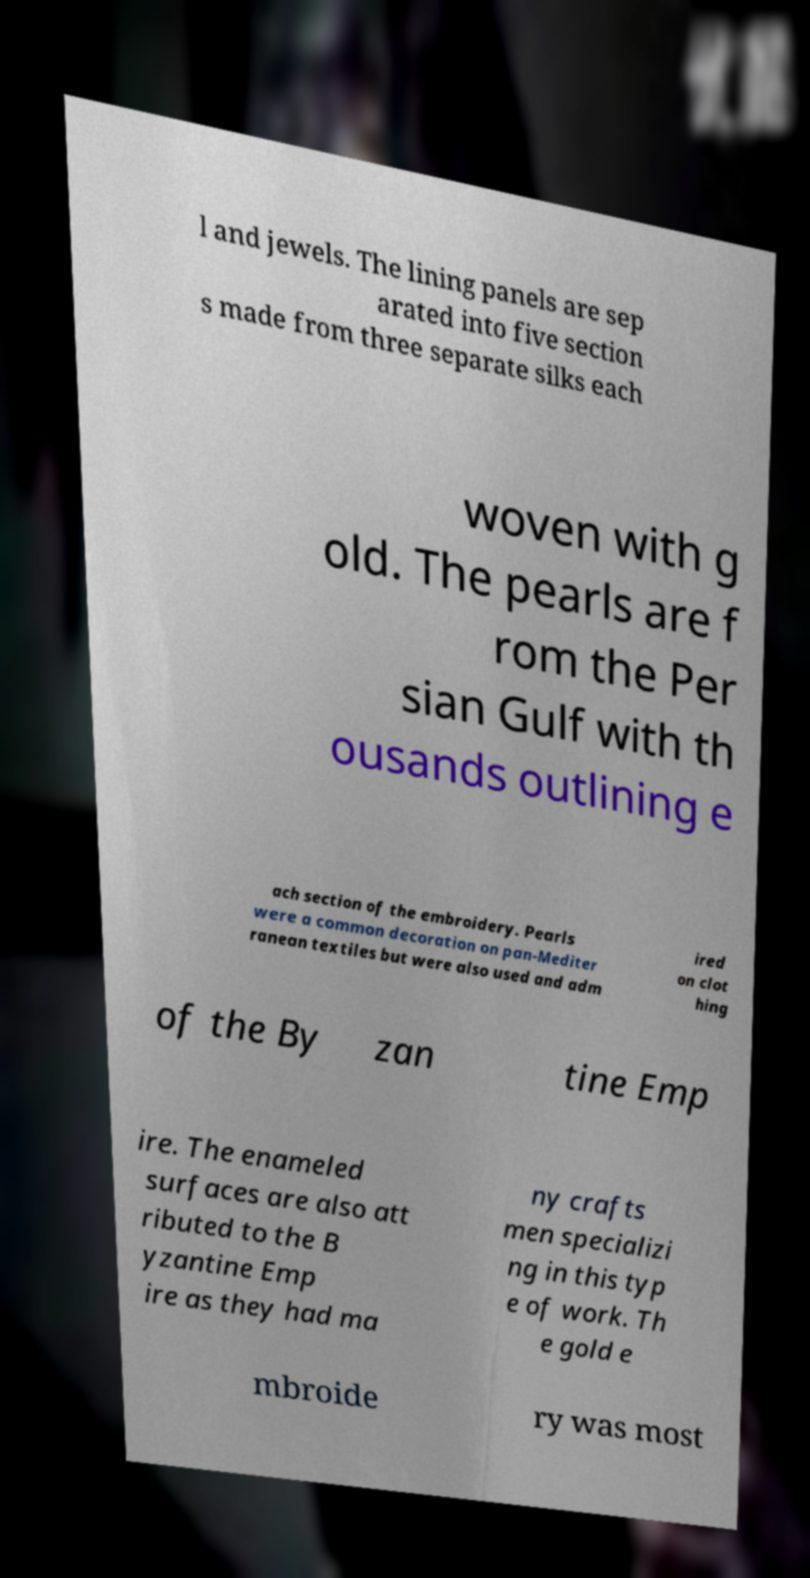Please identify and transcribe the text found in this image. l and jewels. The lining panels are sep arated into five section s made from three separate silks each woven with g old. The pearls are f rom the Per sian Gulf with th ousands outlining e ach section of the embroidery. Pearls were a common decoration on pan-Mediter ranean textiles but were also used and adm ired on clot hing of the By zan tine Emp ire. The enameled surfaces are also att ributed to the B yzantine Emp ire as they had ma ny crafts men specializi ng in this typ e of work. Th e gold e mbroide ry was most 